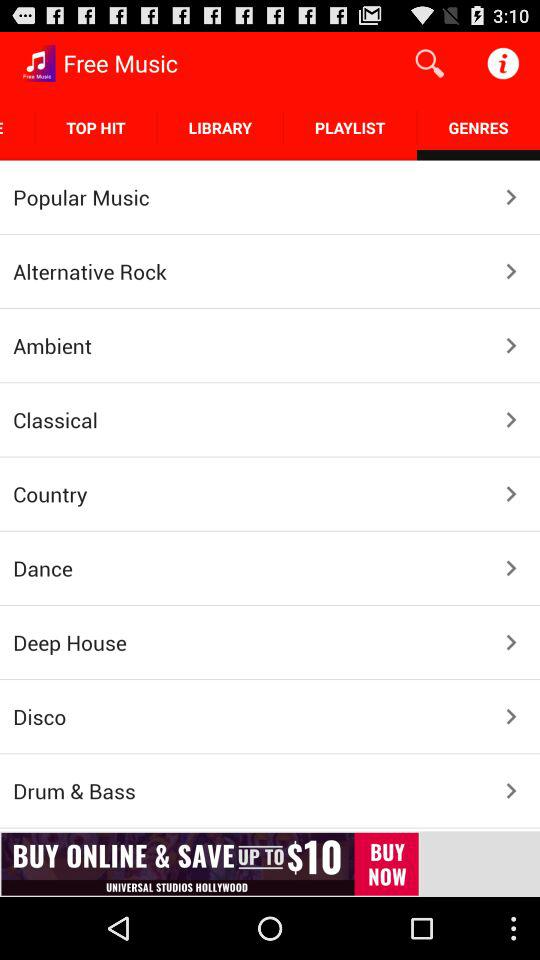Which is the selected tab? The selected tab is "GENRES". 